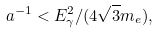<formula> <loc_0><loc_0><loc_500><loc_500>a ^ { - 1 } < E _ { \gamma } ^ { 2 } / ( 4 \sqrt { 3 } m _ { e } ) ,</formula> 